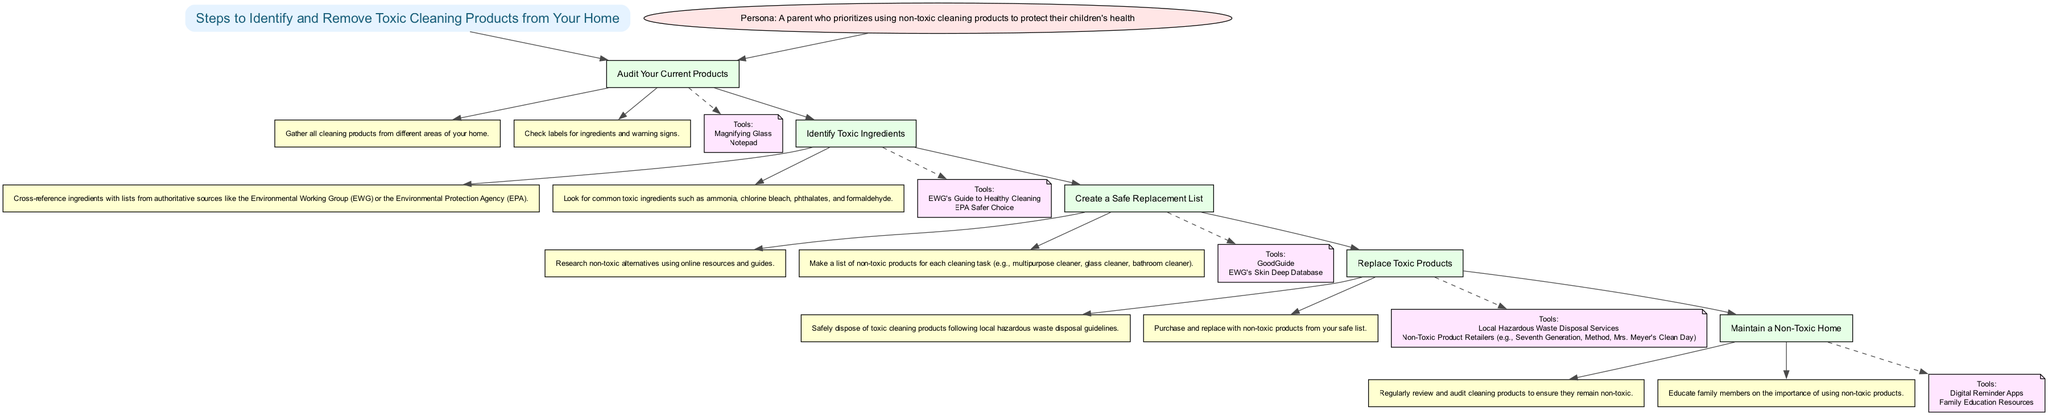What is the first step in the clinical pathway? The first step listed in the diagram is "Audit Your Current Products." It's the first node connected to the title node.
Answer: Audit Your Current Products How many steps are in the pathway? The diagram contains five distinct steps that lead from the title to the final action of the clinical pathway.
Answer: Five What tool is used to check cleaning product labels? The tool mentioned for checking labels is a "Magnifying Glass," as identified in the tools section of the first step.
Answer: Magnifying Glass What common toxic ingredient should be looked for? One common toxic ingredient to look for is "ammonia," which is explicitly mentioned in the second step about identifying toxic ingredients.
Answer: Ammonia What is the last action in the clinical pathway? The last action listed in the diagram is "Educate family members on the importance of using non-toxic products," which is the final action tied to maintaining a non-toxic home.
Answer: Educate family members on the importance of using non-toxic products What are the tools for disposing of toxic cleaning products? The tools listed for safely disposing of toxic cleaning products include "Local Hazardous Waste Disposal Services," which corresponds to the fourth step about replacing toxic products.
Answer: Local Hazardous Waste Disposal Services Which step involves creating a safe replacement list? The step that involves creating a safe replacement list is "Create a Safe Replacement List," as indicated in the third step of the clinical pathway.
Answer: Create a Safe Replacement List Which organization is referenced for identifying toxic ingredients? The Environmental Working Group (EWG) is referenced in the second step for cross-referencing ingredients with lists of toxic substances.
Answer: Environmental Working Group (EWG) What is the main purpose of the clinical pathway? The main purpose of the clinical pathway is to guide individuals in "Identifying and Removing Toxic Cleaning Products from Your Home," as stated in the title of the pathway.
Answer: Identifying and Removing Toxic Cleaning Products from Your Home 